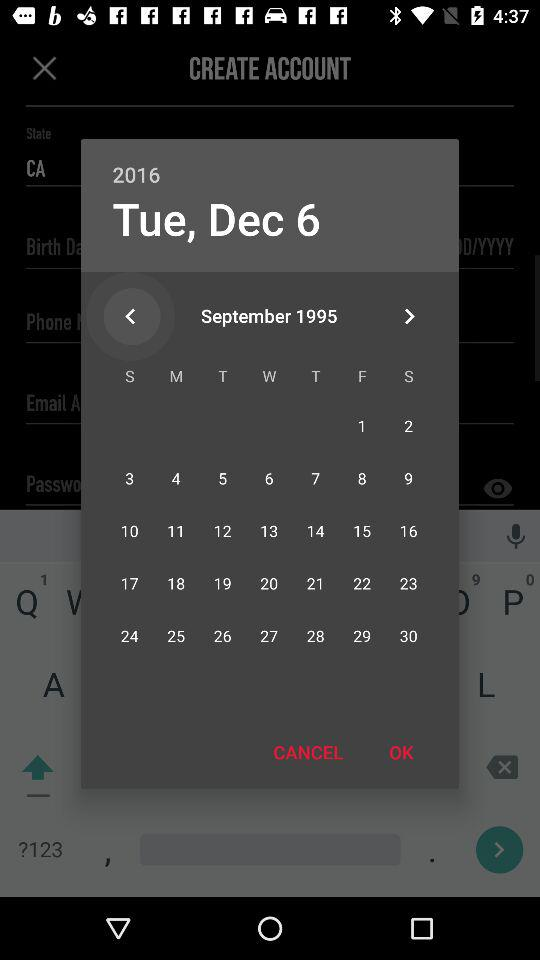What is the selected date? The selected date is Tuesday, December 6, 2016. 